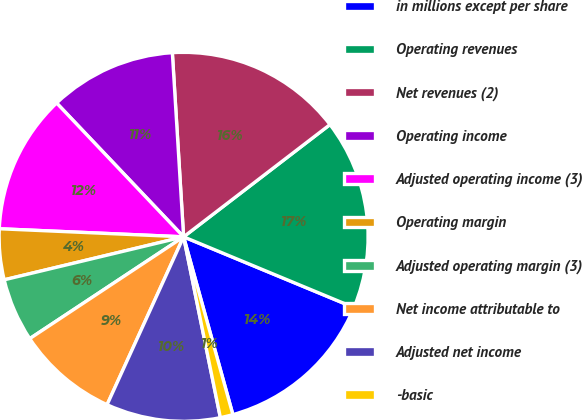Convert chart. <chart><loc_0><loc_0><loc_500><loc_500><pie_chart><fcel>in millions except per share<fcel>Operating revenues<fcel>Net revenues (2)<fcel>Operating income<fcel>Adjusted operating income (3)<fcel>Operating margin<fcel>Adjusted operating margin (3)<fcel>Net income attributable to<fcel>Adjusted net income<fcel>-basic<nl><fcel>14.44%<fcel>16.67%<fcel>15.56%<fcel>11.11%<fcel>12.22%<fcel>4.44%<fcel>5.56%<fcel>8.89%<fcel>10.0%<fcel>1.11%<nl></chart> 